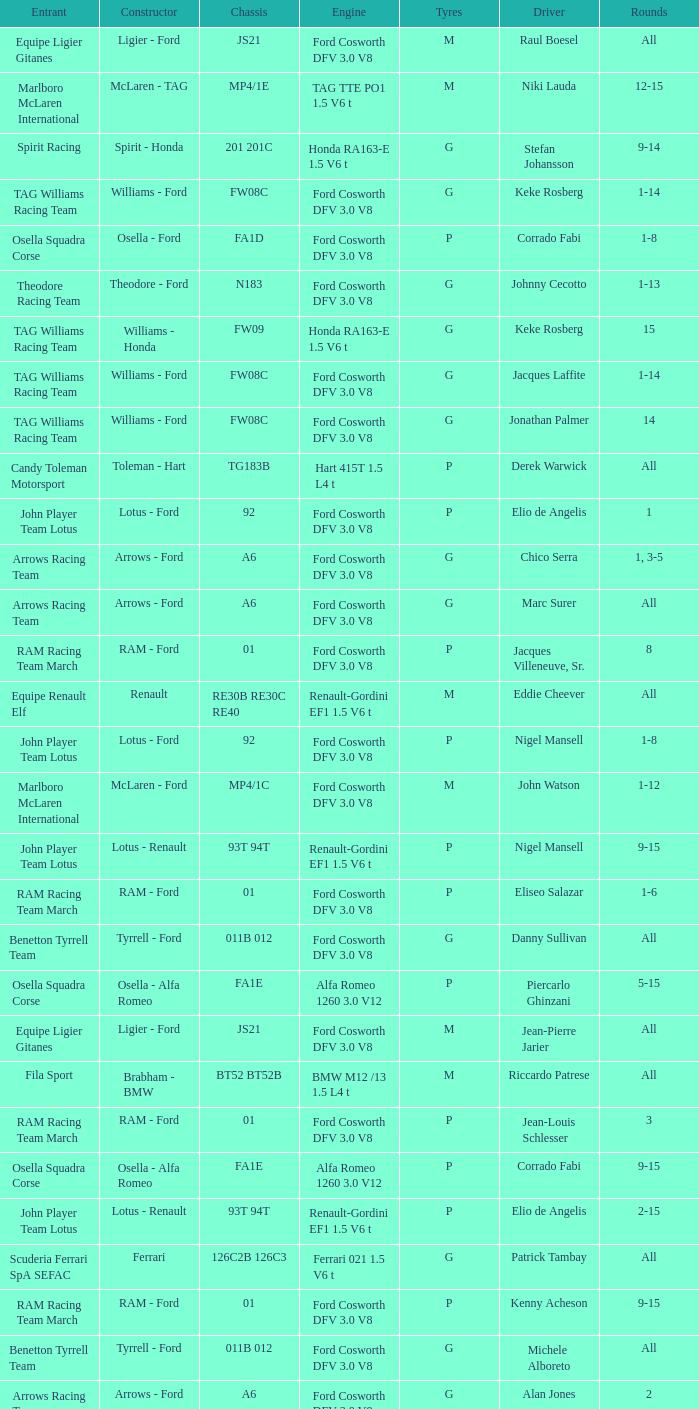Who is driver of the d6 chassis? Manfred Winkelhock. 